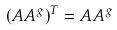<formula> <loc_0><loc_0><loc_500><loc_500>( A A ^ { g } ) ^ { T } = A A ^ { g }</formula> 